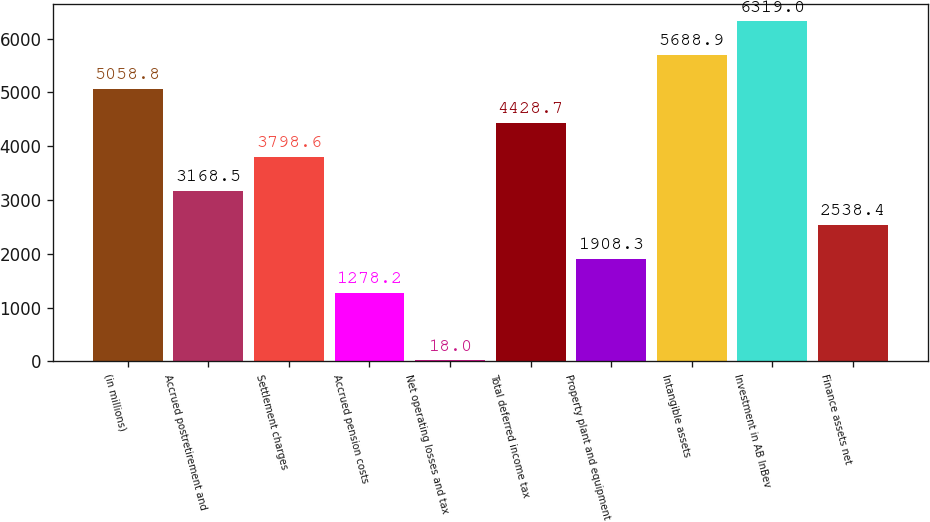<chart> <loc_0><loc_0><loc_500><loc_500><bar_chart><fcel>(in millions)<fcel>Accrued postretirement and<fcel>Settlement charges<fcel>Accrued pension costs<fcel>Net operating losses and tax<fcel>Total deferred income tax<fcel>Property plant and equipment<fcel>Intangible assets<fcel>Investment in AB InBev<fcel>Finance assets net<nl><fcel>5058.8<fcel>3168.5<fcel>3798.6<fcel>1278.2<fcel>18<fcel>4428.7<fcel>1908.3<fcel>5688.9<fcel>6319<fcel>2538.4<nl></chart> 